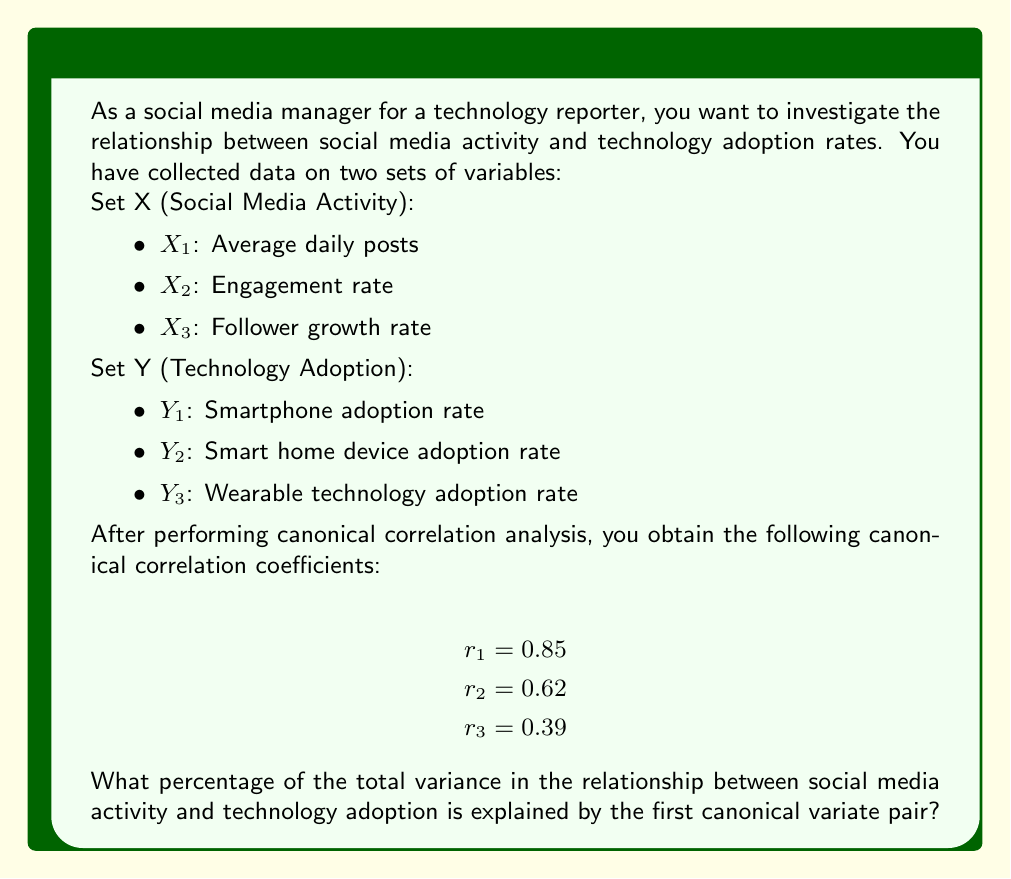Provide a solution to this math problem. To solve this problem, we need to understand the concept of canonical correlation analysis and how to interpret its results. Canonical correlation analysis explores the relationships between two sets of variables by finding linear combinations of each set that have maximum correlation with each other.

The canonical correlation coefficients ($r_1$, $r_2$, $r_3$) represent the strength of the relationship between each pair of canonical variates. The square of each coefficient ($r_i^2$) represents the amount of variance shared between the $i$-th pair of canonical variates.

To calculate the percentage of total variance explained by the first canonical variate pair, we need to follow these steps:

1. Calculate the squared canonical correlation coefficients:
   $r_1^2 = 0.85^2 = 0.7225$
   $r_2^2 = 0.62^2 = 0.3844$
   $r_3^2 = 0.39^2 = 0.1521$

2. Calculate the sum of all squared canonical correlation coefficients:
   $\sum_{i=1}^{3} r_i^2 = 0.7225 + 0.3844 + 0.1521 = 1.2590$

3. Calculate the proportion of variance explained by the first canonical variate pair:
   $\frac{r_1^2}{\sum_{i=1}^{3} r_i^2} = \frac{0.7225}{1.2590} = 0.5739$

4. Convert the proportion to a percentage:
   $0.5739 \times 100\% = 57.39\%$

Therefore, the first canonical variate pair explains 57.39% of the total variance in the relationship between social media activity and technology adoption.
Answer: 57.39% 